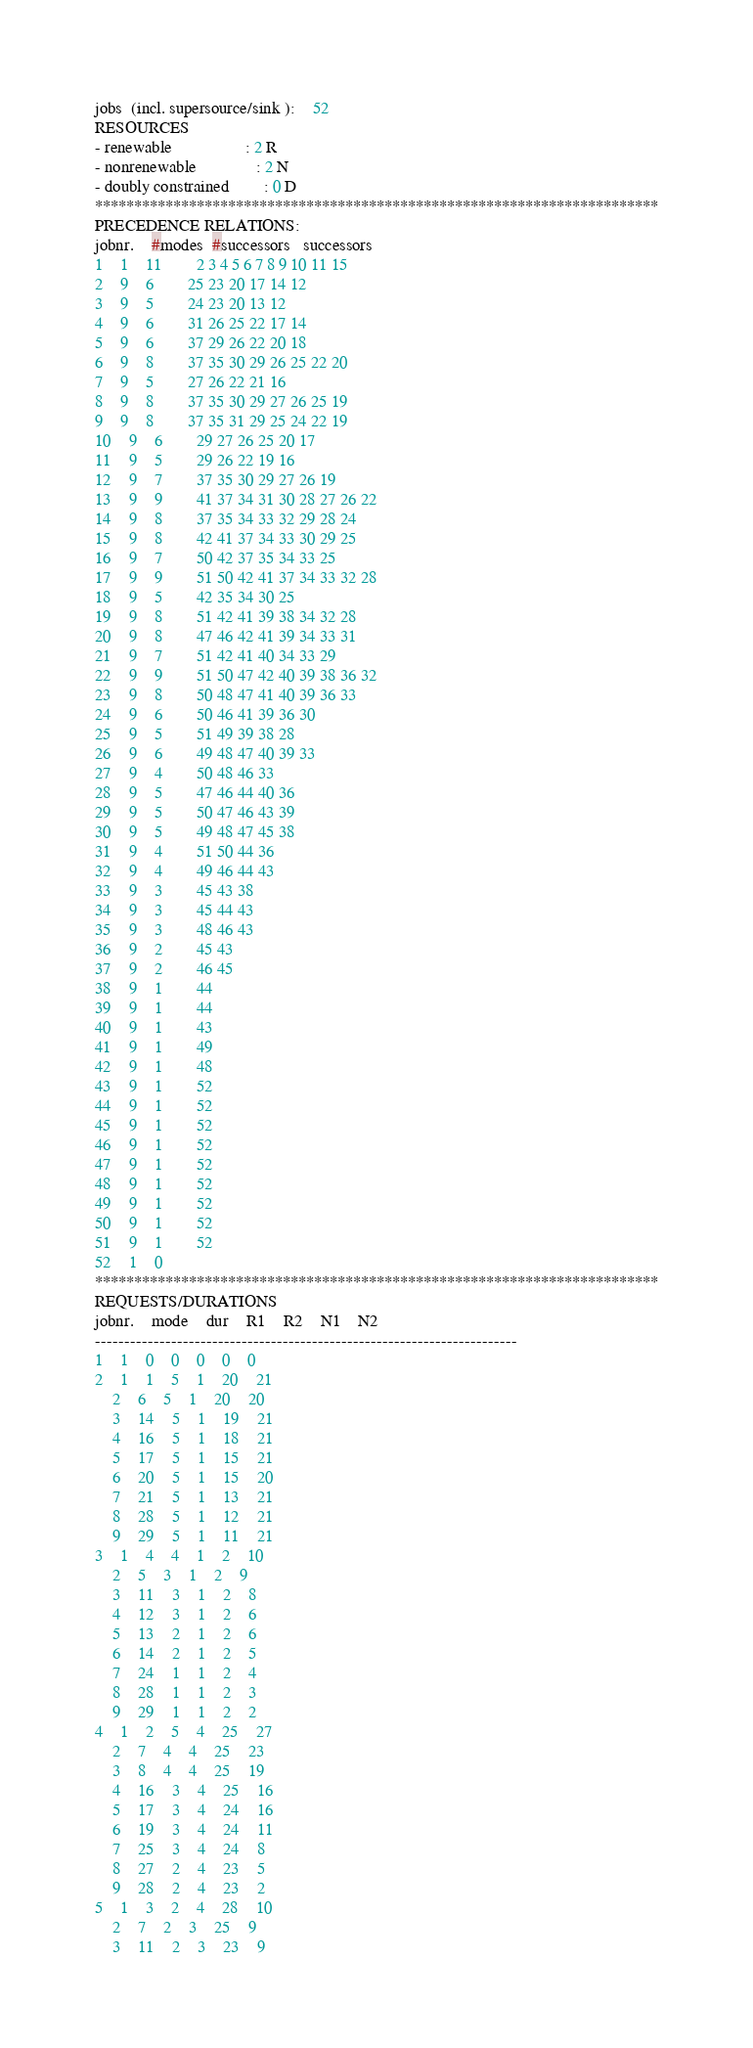Convert code to text. <code><loc_0><loc_0><loc_500><loc_500><_ObjectiveC_>jobs  (incl. supersource/sink ):	52
RESOURCES
- renewable                 : 2 R
- nonrenewable              : 2 N
- doubly constrained        : 0 D
************************************************************************
PRECEDENCE RELATIONS:
jobnr.    #modes  #successors   successors
1	1	11		2 3 4 5 6 7 8 9 10 11 15 
2	9	6		25 23 20 17 14 12 
3	9	5		24 23 20 13 12 
4	9	6		31 26 25 22 17 14 
5	9	6		37 29 26 22 20 18 
6	9	8		37 35 30 29 26 25 22 20 
7	9	5		27 26 22 21 16 
8	9	8		37 35 30 29 27 26 25 19 
9	9	8		37 35 31 29 25 24 22 19 
10	9	6		29 27 26 25 20 17 
11	9	5		29 26 22 19 16 
12	9	7		37 35 30 29 27 26 19 
13	9	9		41 37 34 31 30 28 27 26 22 
14	9	8		37 35 34 33 32 29 28 24 
15	9	8		42 41 37 34 33 30 29 25 
16	9	7		50 42 37 35 34 33 25 
17	9	9		51 50 42 41 37 34 33 32 28 
18	9	5		42 35 34 30 25 
19	9	8		51 42 41 39 38 34 32 28 
20	9	8		47 46 42 41 39 34 33 31 
21	9	7		51 42 41 40 34 33 29 
22	9	9		51 50 47 42 40 39 38 36 32 
23	9	8		50 48 47 41 40 39 36 33 
24	9	6		50 46 41 39 36 30 
25	9	5		51 49 39 38 28 
26	9	6		49 48 47 40 39 33 
27	9	4		50 48 46 33 
28	9	5		47 46 44 40 36 
29	9	5		50 47 46 43 39 
30	9	5		49 48 47 45 38 
31	9	4		51 50 44 36 
32	9	4		49 46 44 43 
33	9	3		45 43 38 
34	9	3		45 44 43 
35	9	3		48 46 43 
36	9	2		45 43 
37	9	2		46 45 
38	9	1		44 
39	9	1		44 
40	9	1		43 
41	9	1		49 
42	9	1		48 
43	9	1		52 
44	9	1		52 
45	9	1		52 
46	9	1		52 
47	9	1		52 
48	9	1		52 
49	9	1		52 
50	9	1		52 
51	9	1		52 
52	1	0		
************************************************************************
REQUESTS/DURATIONS
jobnr.	mode	dur	R1	R2	N1	N2	
------------------------------------------------------------------------
1	1	0	0	0	0	0	
2	1	1	5	1	20	21	
	2	6	5	1	20	20	
	3	14	5	1	19	21	
	4	16	5	1	18	21	
	5	17	5	1	15	21	
	6	20	5	1	15	20	
	7	21	5	1	13	21	
	8	28	5	1	12	21	
	9	29	5	1	11	21	
3	1	4	4	1	2	10	
	2	5	3	1	2	9	
	3	11	3	1	2	8	
	4	12	3	1	2	6	
	5	13	2	1	2	6	
	6	14	2	1	2	5	
	7	24	1	1	2	4	
	8	28	1	1	2	3	
	9	29	1	1	2	2	
4	1	2	5	4	25	27	
	2	7	4	4	25	23	
	3	8	4	4	25	19	
	4	16	3	4	25	16	
	5	17	3	4	24	16	
	6	19	3	4	24	11	
	7	25	3	4	24	8	
	8	27	2	4	23	5	
	9	28	2	4	23	2	
5	1	3	2	4	28	10	
	2	7	2	3	25	9	
	3	11	2	3	23	9	</code> 